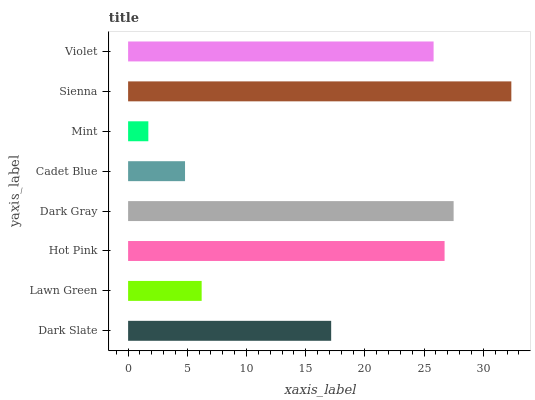Is Mint the minimum?
Answer yes or no. Yes. Is Sienna the maximum?
Answer yes or no. Yes. Is Lawn Green the minimum?
Answer yes or no. No. Is Lawn Green the maximum?
Answer yes or no. No. Is Dark Slate greater than Lawn Green?
Answer yes or no. Yes. Is Lawn Green less than Dark Slate?
Answer yes or no. Yes. Is Lawn Green greater than Dark Slate?
Answer yes or no. No. Is Dark Slate less than Lawn Green?
Answer yes or no. No. Is Violet the high median?
Answer yes or no. Yes. Is Dark Slate the low median?
Answer yes or no. Yes. Is Hot Pink the high median?
Answer yes or no. No. Is Lawn Green the low median?
Answer yes or no. No. 